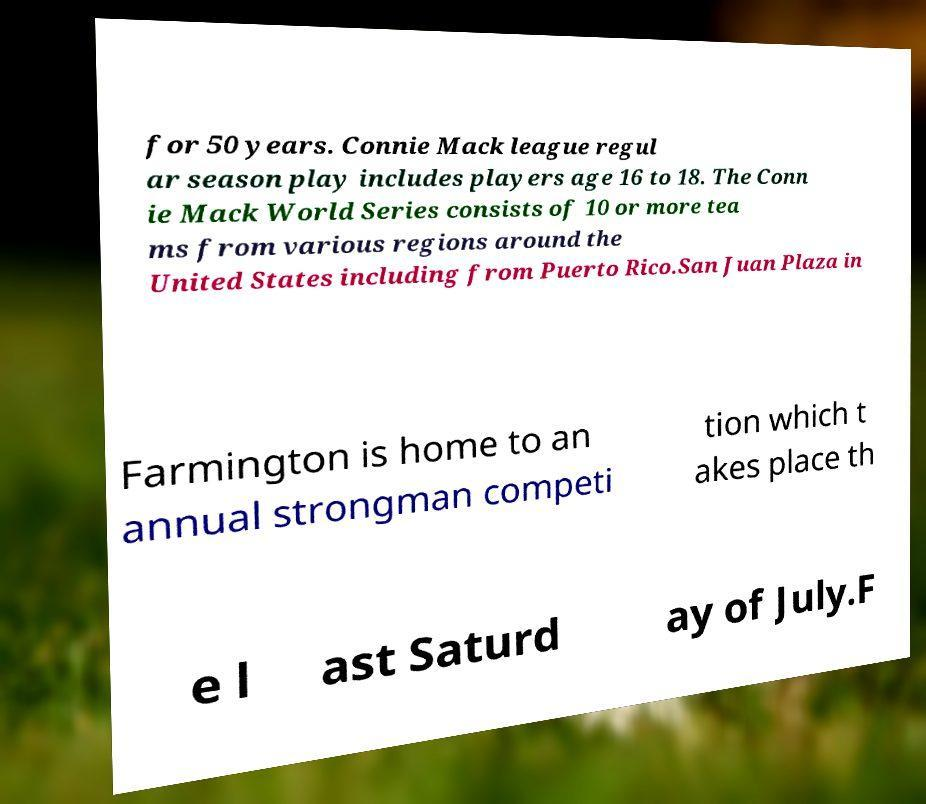Please identify and transcribe the text found in this image. for 50 years. Connie Mack league regul ar season play includes players age 16 to 18. The Conn ie Mack World Series consists of 10 or more tea ms from various regions around the United States including from Puerto Rico.San Juan Plaza in Farmington is home to an annual strongman competi tion which t akes place th e l ast Saturd ay of July.F 